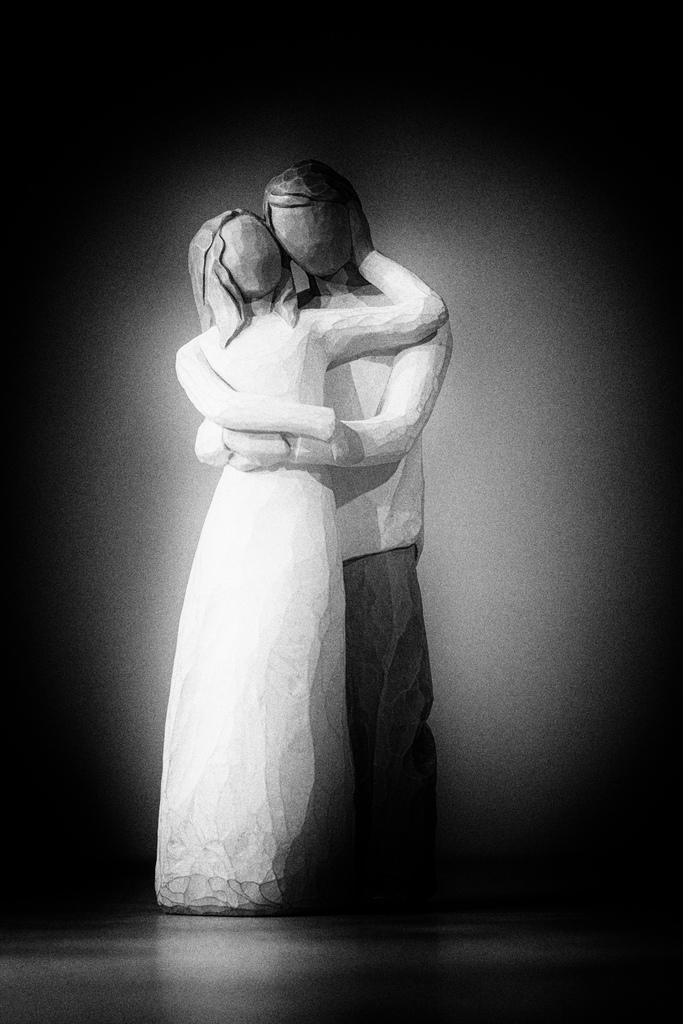What type of dolls are in the image? There are two wooden dolls in the image. How are the dolls dressed? Both dolls are dressed in white. What do the dolls represent? One doll represents a man, and the other represents a woman. What is the color of the background in the image? The background of the image is black in color. What type of toothbrush is the pet using in the image? There is no toothbrush or pet present in the image. What achievements has the achiever accomplished in the image? There is no achiever or any achievements mentioned in the image. 